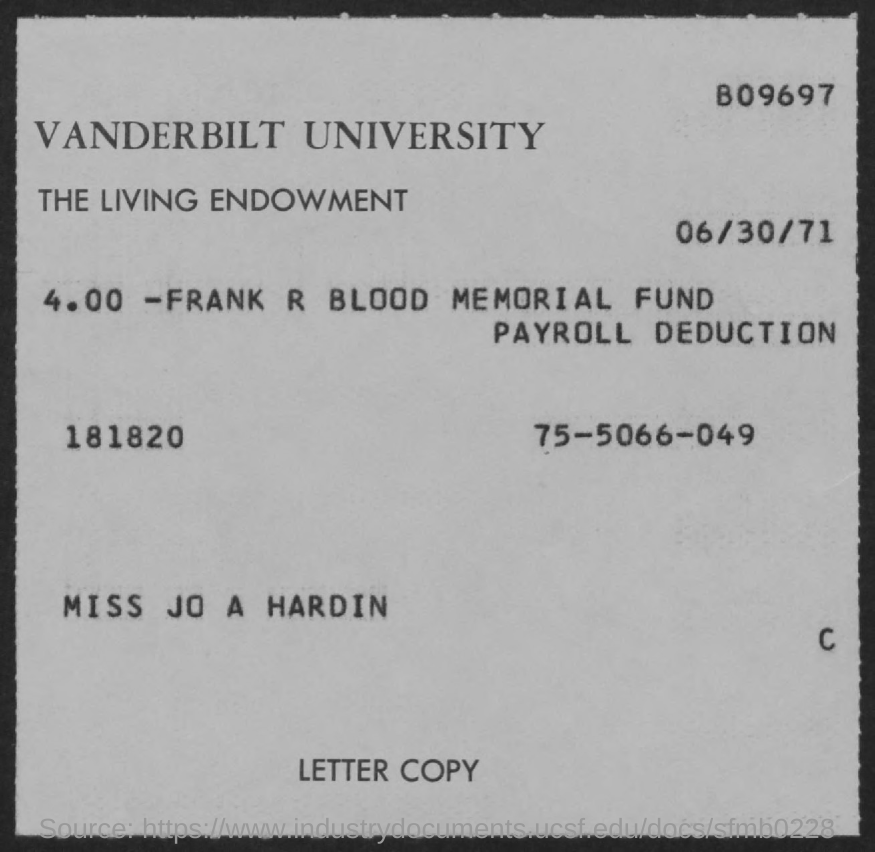Indicate a few pertinent items in this graphic. The date mentioned in the document is June 30, 1971. Vanderbilt University is the first title mentioned in the document. 